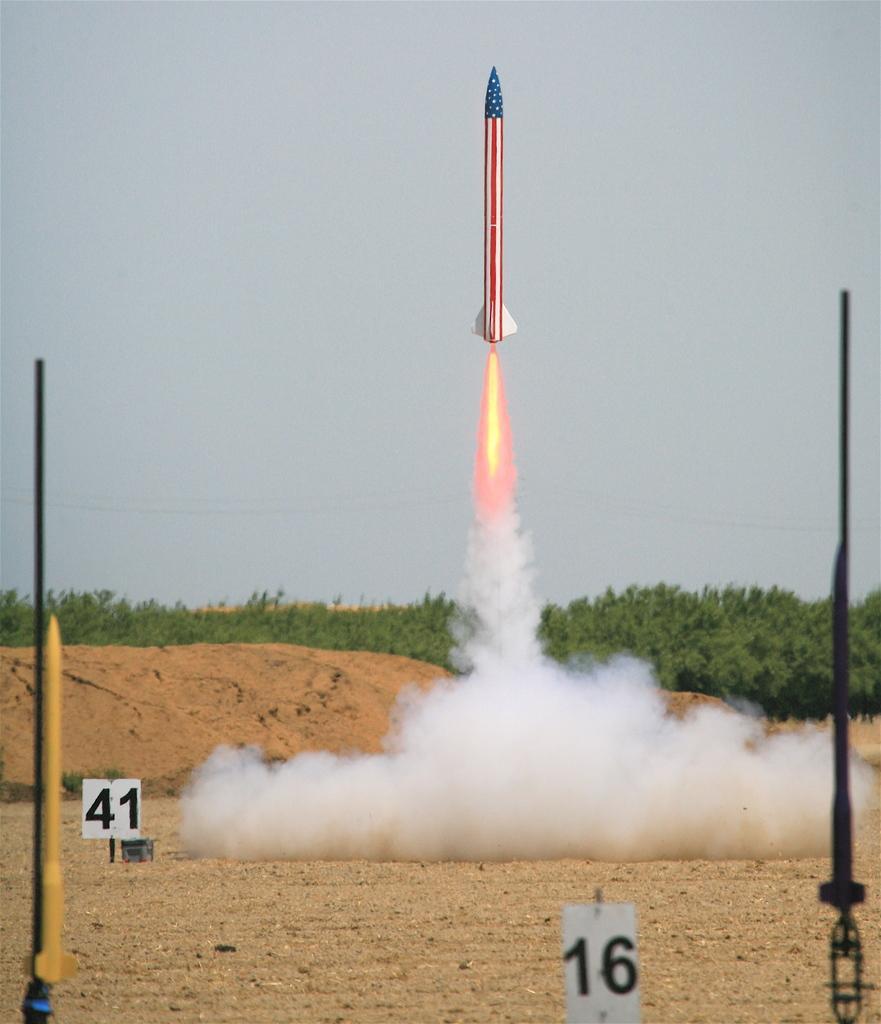Can you describe this image briefly? In this image I see the white smoke over here and I see the ground and I see 2 black color things on either sides and I see 2 white poles on which there are numbers and I see a yellow color thing over here. In the background I see the trees, sky and a missile which is of red, white and blue in color and I see the fire over here. 